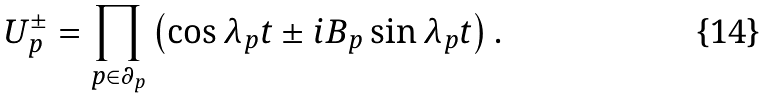<formula> <loc_0><loc_0><loc_500><loc_500>U ^ { \pm } _ { p } = \prod _ { p \in \partial _ { p } } \left ( \cos \lambda _ { p } t \pm i B _ { p } \sin \lambda _ { p } t \right ) .</formula> 